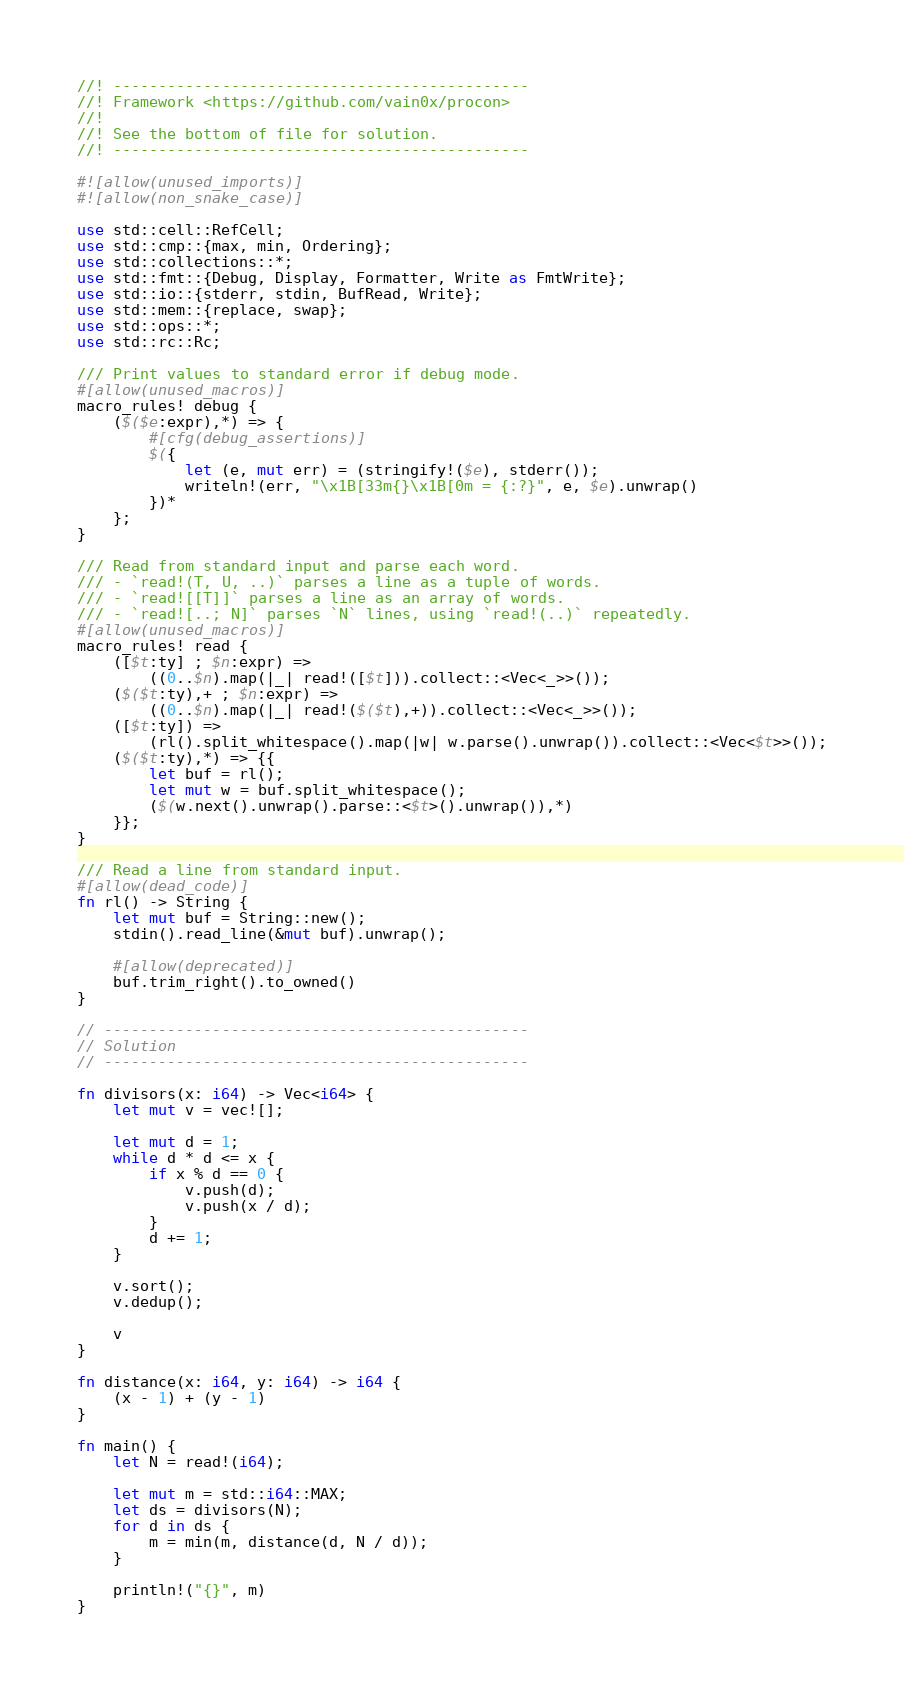Convert code to text. <code><loc_0><loc_0><loc_500><loc_500><_Rust_>//! ----------------------------------------------
//! Framework <https://github.com/vain0x/procon>
//!
//! See the bottom of file for solution.
//! ----------------------------------------------

#![allow(unused_imports)]
#![allow(non_snake_case)]

use std::cell::RefCell;
use std::cmp::{max, min, Ordering};
use std::collections::*;
use std::fmt::{Debug, Display, Formatter, Write as FmtWrite};
use std::io::{stderr, stdin, BufRead, Write};
use std::mem::{replace, swap};
use std::ops::*;
use std::rc::Rc;

/// Print values to standard error if debug mode.
#[allow(unused_macros)]
macro_rules! debug {
    ($($e:expr),*) => {
        #[cfg(debug_assertions)]
        $({
            let (e, mut err) = (stringify!($e), stderr());
            writeln!(err, "\x1B[33m{}\x1B[0m = {:?}", e, $e).unwrap()
        })*
    };
}

/// Read from standard input and parse each word.
/// - `read!(T, U, ..)` parses a line as a tuple of words.
/// - `read![[T]]` parses a line as an array of words.
/// - `read![..; N]` parses `N` lines, using `read!(..)` repeatedly.
#[allow(unused_macros)]
macro_rules! read {
    ([$t:ty] ; $n:expr) =>
        ((0..$n).map(|_| read!([$t])).collect::<Vec<_>>());
    ($($t:ty),+ ; $n:expr) =>
        ((0..$n).map(|_| read!($($t),+)).collect::<Vec<_>>());
    ([$t:ty]) =>
        (rl().split_whitespace().map(|w| w.parse().unwrap()).collect::<Vec<$t>>());
    ($($t:ty),*) => {{
        let buf = rl();
        let mut w = buf.split_whitespace();
        ($(w.next().unwrap().parse::<$t>().unwrap()),*)
    }};
}

/// Read a line from standard input.
#[allow(dead_code)]
fn rl() -> String {
    let mut buf = String::new();
    stdin().read_line(&mut buf).unwrap();

    #[allow(deprecated)]
    buf.trim_right().to_owned()
}

// -----------------------------------------------
// Solution
// -----------------------------------------------

fn divisors(x: i64) -> Vec<i64> {
    let mut v = vec![];

    let mut d = 1;
    while d * d <= x {
        if x % d == 0 {
            v.push(d);
            v.push(x / d);
        }
        d += 1;
    }

    v.sort();
    v.dedup();

    v
}

fn distance(x: i64, y: i64) -> i64 {
    (x - 1) + (y - 1)
}

fn main() {
    let N = read!(i64);

    let mut m = std::i64::MAX;
    let ds = divisors(N);
    for d in ds {
        m = min(m, distance(d, N / d));
    }

    println!("{}", m)
}
</code> 